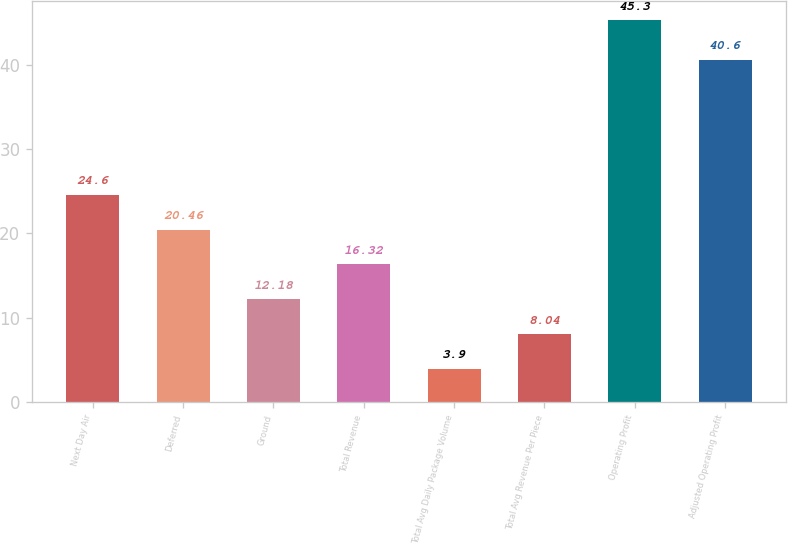Convert chart to OTSL. <chart><loc_0><loc_0><loc_500><loc_500><bar_chart><fcel>Next Day Air<fcel>Deferred<fcel>Ground<fcel>Total Revenue<fcel>Total Avg Daily Package Volume<fcel>Total Avg Revenue Per Piece<fcel>Operating Profit<fcel>Adjusted Operating Profit<nl><fcel>24.6<fcel>20.46<fcel>12.18<fcel>16.32<fcel>3.9<fcel>8.04<fcel>45.3<fcel>40.6<nl></chart> 